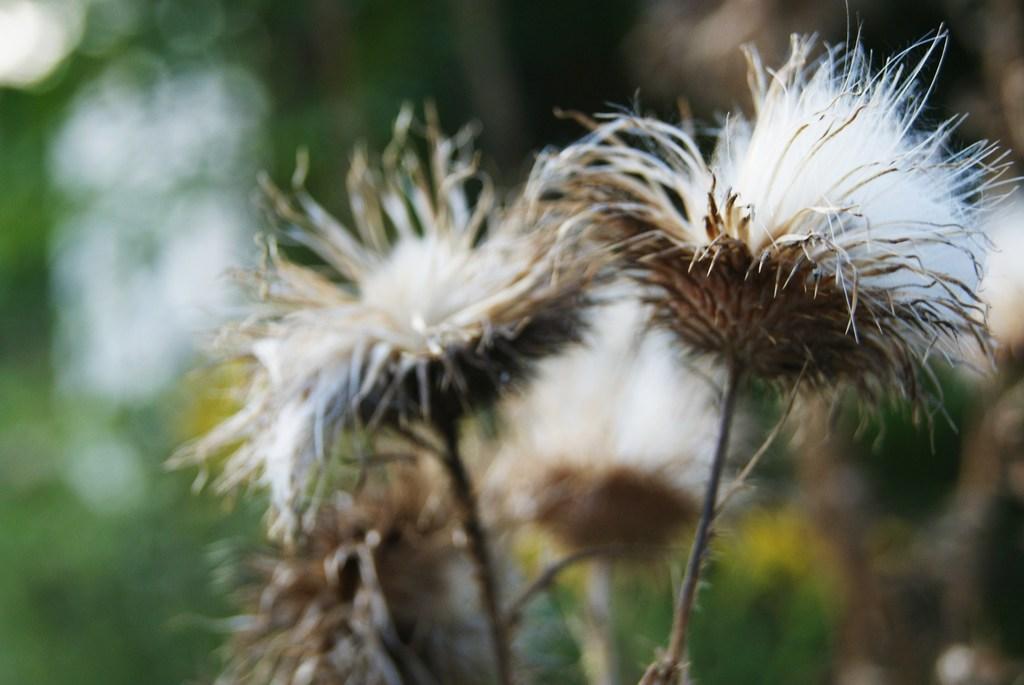Could you give a brief overview of what you see in this image? These are the dried flowers. 